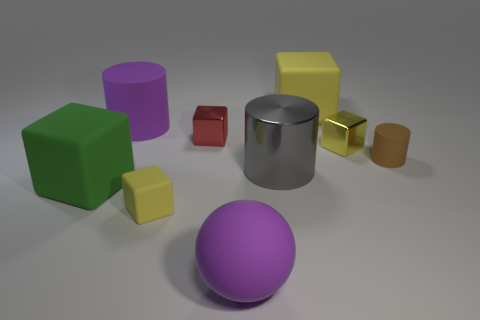What size is the block behind the large purple object on the left side of the red cube?
Your answer should be compact. Large. What is the color of the other shiny object that is the same shape as the tiny red object?
Offer a very short reply. Yellow. How many tiny matte things are the same color as the big rubber sphere?
Provide a short and direct response. 0. The yellow shiny cube is what size?
Your answer should be compact. Small. Do the brown matte object and the gray metal object have the same size?
Offer a very short reply. No. There is a rubber thing that is behind the small brown cylinder and to the right of the gray cylinder; what is its color?
Your answer should be very brief. Yellow. How many purple balls are the same material as the green object?
Your response must be concise. 1. How many tiny gray metallic spheres are there?
Ensure brevity in your answer.  0. There is a green rubber object; is it the same size as the gray thing that is behind the green block?
Your response must be concise. Yes. What is the material of the cylinder right of the large gray metal cylinder behind the green matte block?
Offer a terse response. Rubber. 